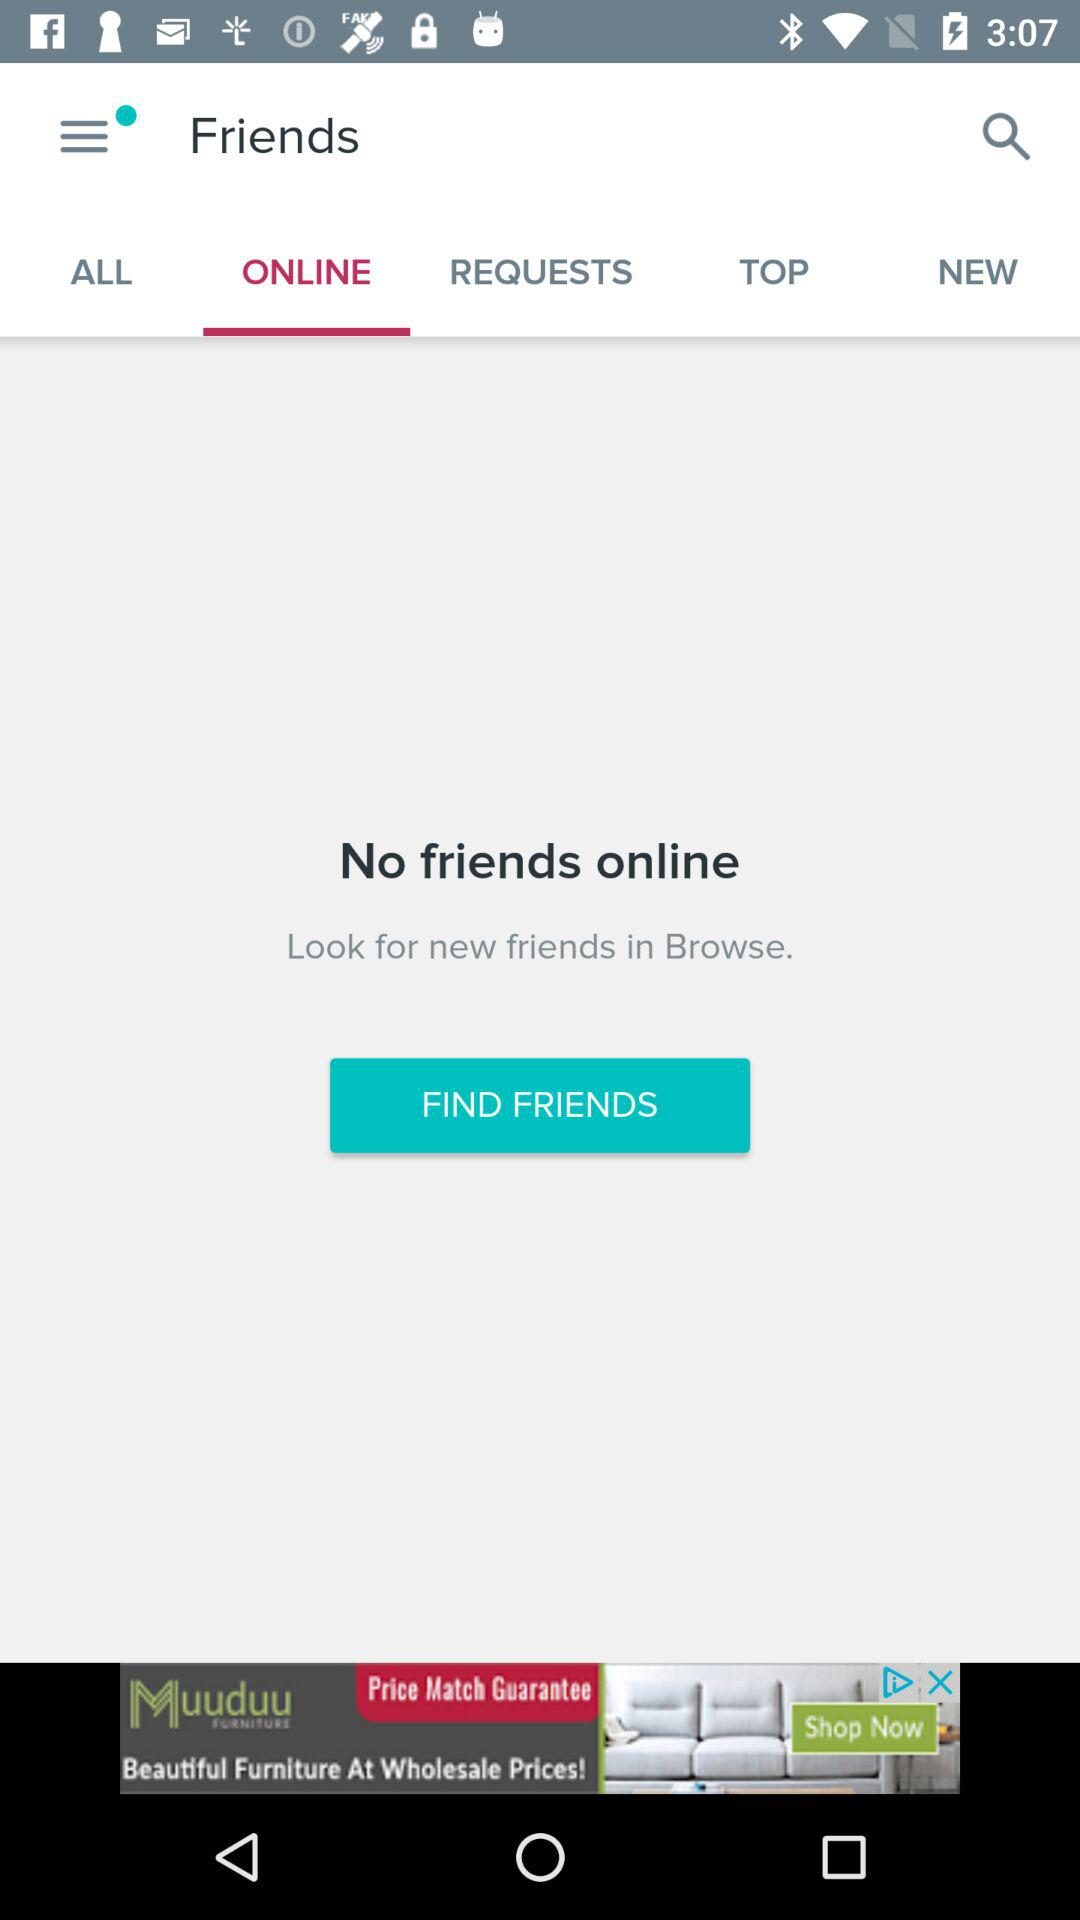How many notifications are there in "NEW"?
When the provided information is insufficient, respond with <no answer>. <no answer> 